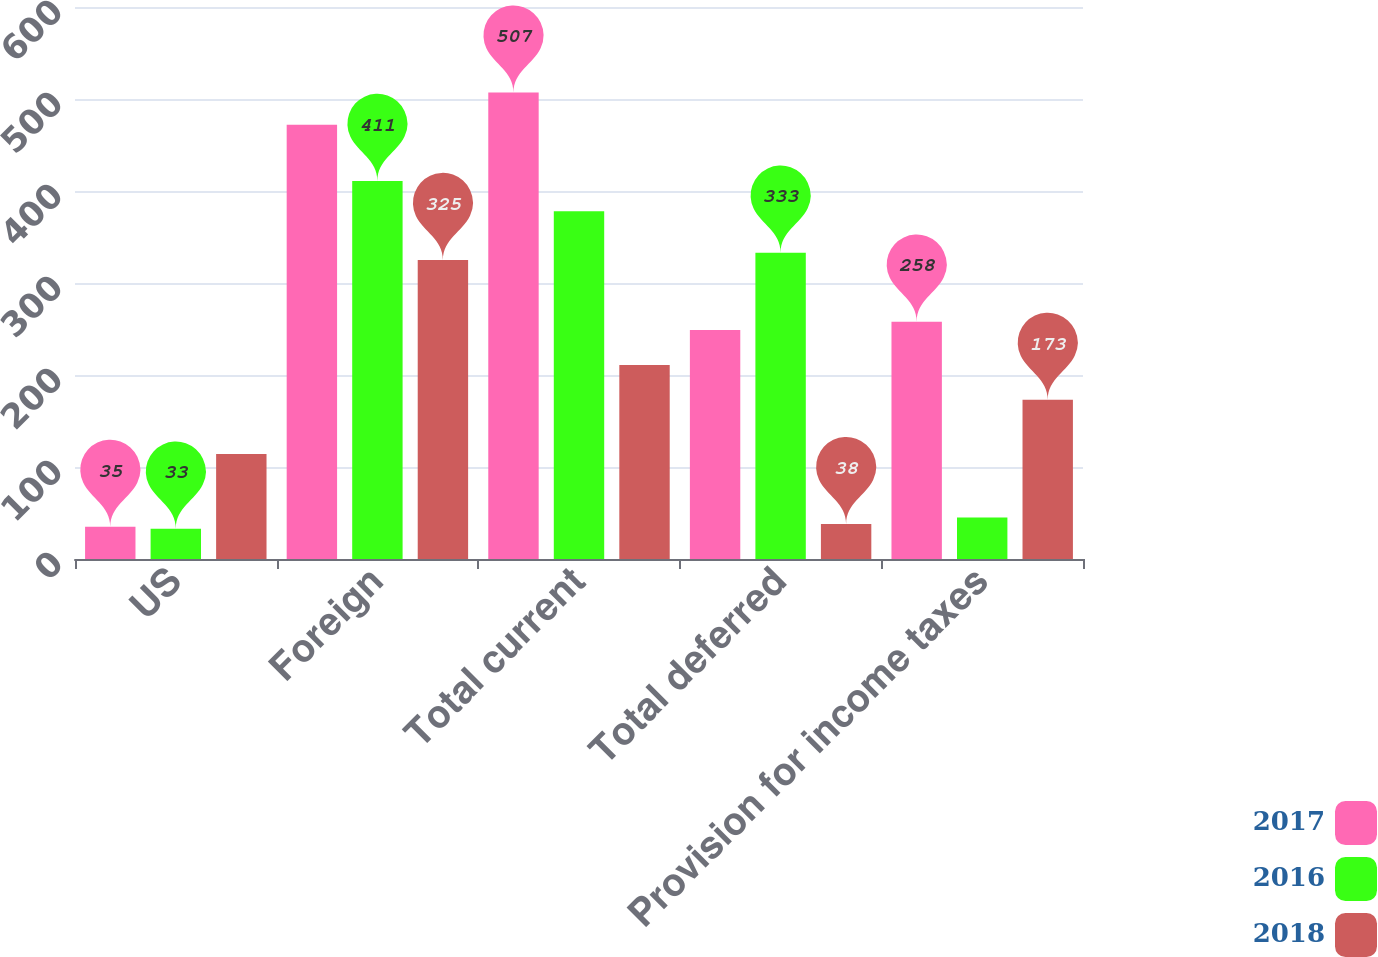Convert chart to OTSL. <chart><loc_0><loc_0><loc_500><loc_500><stacked_bar_chart><ecel><fcel>US<fcel>Foreign<fcel>Total current<fcel>Total deferred<fcel>Provision for income taxes<nl><fcel>2017<fcel>35<fcel>472<fcel>507<fcel>249<fcel>258<nl><fcel>2016<fcel>33<fcel>411<fcel>378<fcel>333<fcel>45<nl><fcel>2018<fcel>114<fcel>325<fcel>211<fcel>38<fcel>173<nl></chart> 